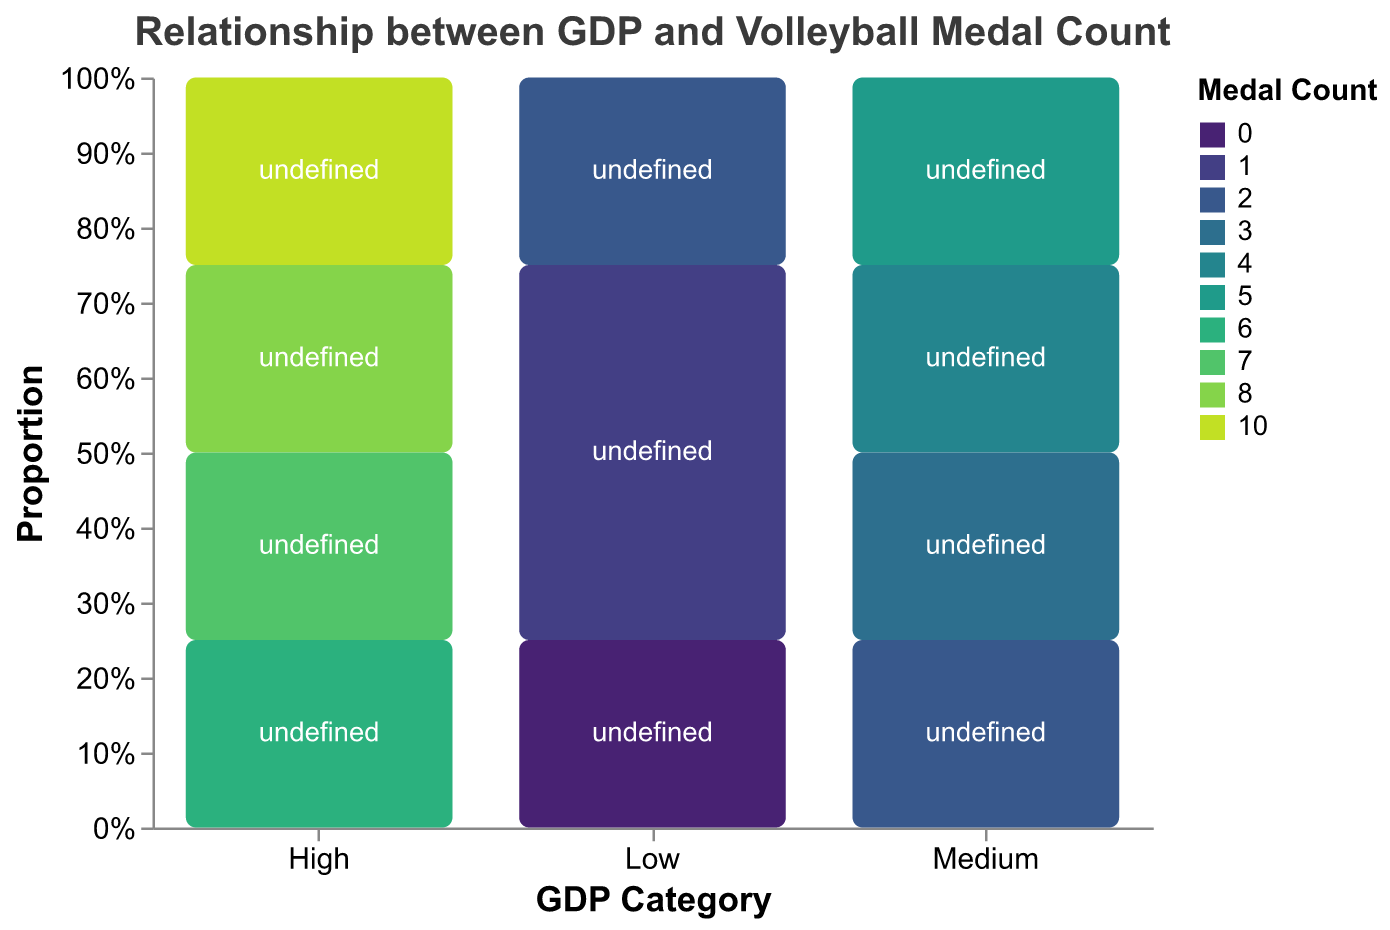What is the title of the plot? The title is usually placed at the top of the plot. Here it reads "Relationship between GDP and Volleyball Medal Count".
Answer: Relationship between GDP and Volleyball Medal Count Which GDP category is associated with the highest total medal count? By examining the mosaic plot, we can see the "High" GDP category has the highest proportional representation in the plot, indicating the highest total medal count.
Answer: High How many countries are represented in the Medium GDP category? In the Medium GDP category, count the individual bars (or segments) with different country labels. There are four segments labeled Poland, Serbia, Japan, and Argentina.
Answer: 4 Compare the medal counts of USA and Brazil. Which country has more medals? Locate the segments labeled "USA" and "Brazil" in the High GDP category. USA has a higher value with a medal count of 10 compared to Brazil's 8.
Answer: USA Which country in the Low GDP category has no medals? In the Low GDP category, look for the segment with a label and a zero value. This segment is labeled "Kenya".
Answer: Kenya What is the medal count for the country with the lowest GDP category and the most medals? In the Low GDP category, identify the highest bar. The highest medal count in this category is 2, represented by Cuba.
Answer: 2 How many countries have their names listed in the High GDP category? Count the unique labels in the High GDP category; they are USA, Brazil, Italy, and Russia, thus four in total.
Answer: 4 Which GDP category has the broadest range of medal counts among its represented countries? By observing the distribution of the sections within each GDP category, notice that the High GDP category shows a wider range of medal counts from 6 to 10.
Answer: High What proportion of total medals does the Medium GDP category represent compared to the High GDP category? To determine the proportion, sum the medals in Medium GDP (5+4+3+2=14) and High GDP (10+8+7+6=31). Then divide 14 by 31 and multiply by 100 to get the percentage.
Answer: 45.16% Which country is the smallest contributor in the High GDP category by medal count, and what is their count? In the High GDP category, the smallest segment by height is "Russia" with a medal count of 6.
Answer: Russia with 6 medals 